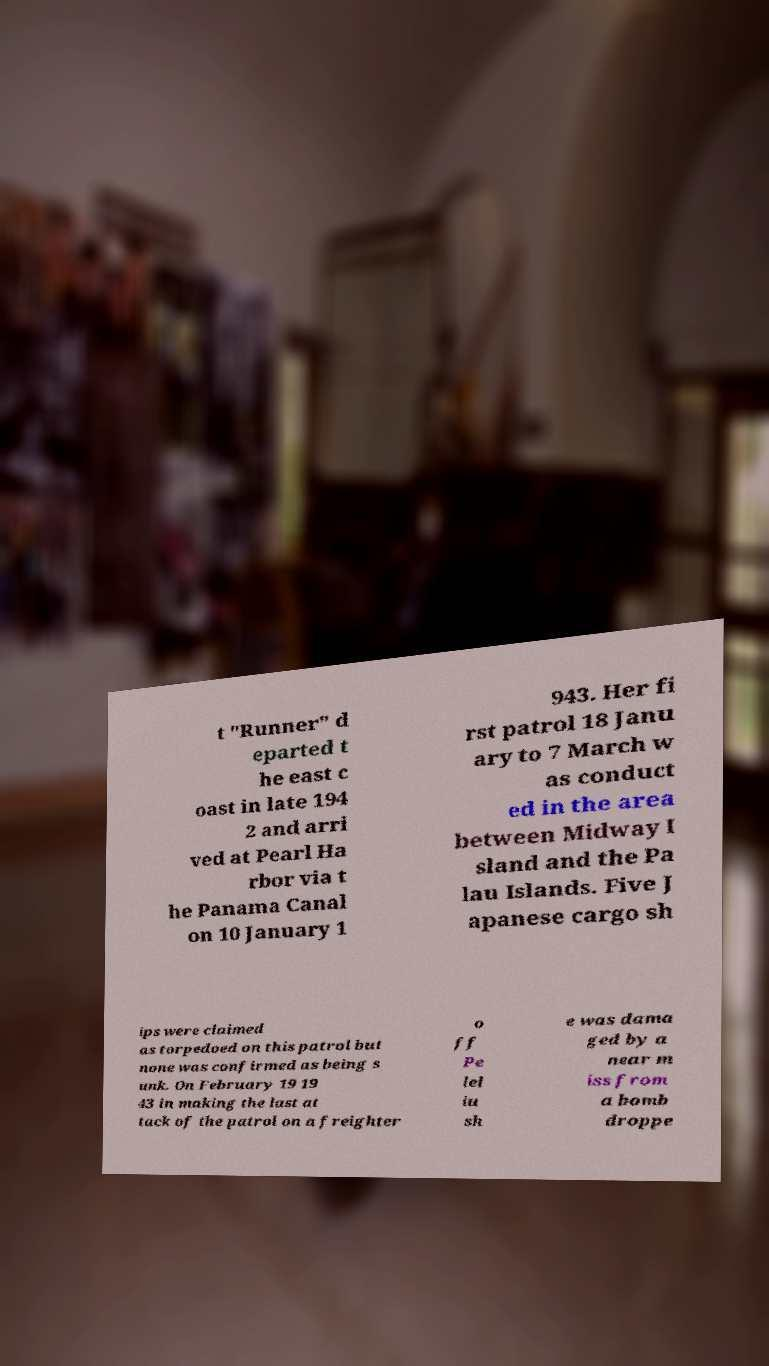Can you accurately transcribe the text from the provided image for me? t "Runner" d eparted t he east c oast in late 194 2 and arri ved at Pearl Ha rbor via t he Panama Canal on 10 January 1 943. Her fi rst patrol 18 Janu ary to 7 March w as conduct ed in the area between Midway I sland and the Pa lau Islands. Five J apanese cargo sh ips were claimed as torpedoed on this patrol but none was confirmed as being s unk. On February 19 19 43 in making the last at tack of the patrol on a freighter o ff Pe lel iu sh e was dama ged by a near m iss from a bomb droppe 